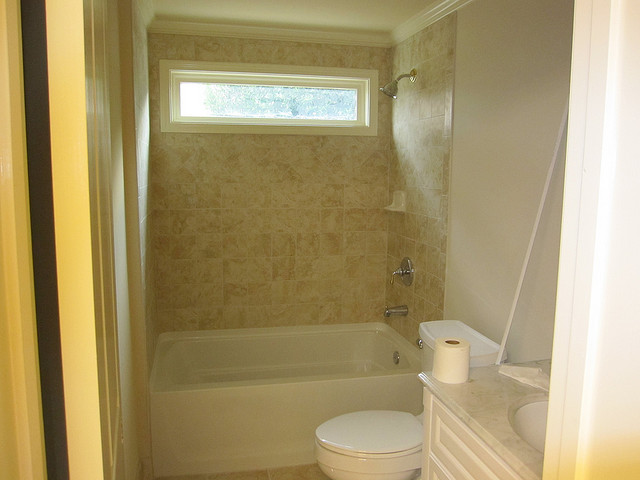Can you describe the style and features of the bathroom shown? The bathroom has a modern and clean design, featuring a standard bathtub with an overhead shower, marble-look wall tiles, and a small, opaque window providing natural light while maintaining privacy. There's a toilet adjacent to the tub and a white vanity cabinet with an undermount sink. 